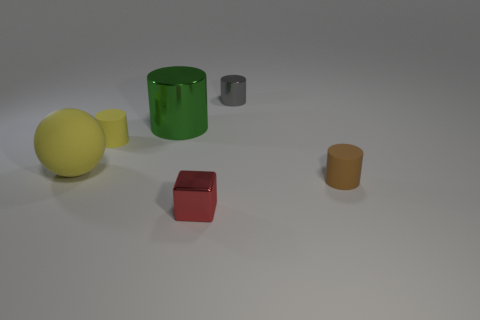Add 4 matte cylinders. How many objects exist? 10 Subtract all cylinders. How many objects are left? 2 Add 5 tiny metallic cylinders. How many tiny metallic cylinders are left? 6 Add 6 large green metal objects. How many large green metal objects exist? 7 Subtract 0 green blocks. How many objects are left? 6 Subtract all brown matte things. Subtract all big green cylinders. How many objects are left? 4 